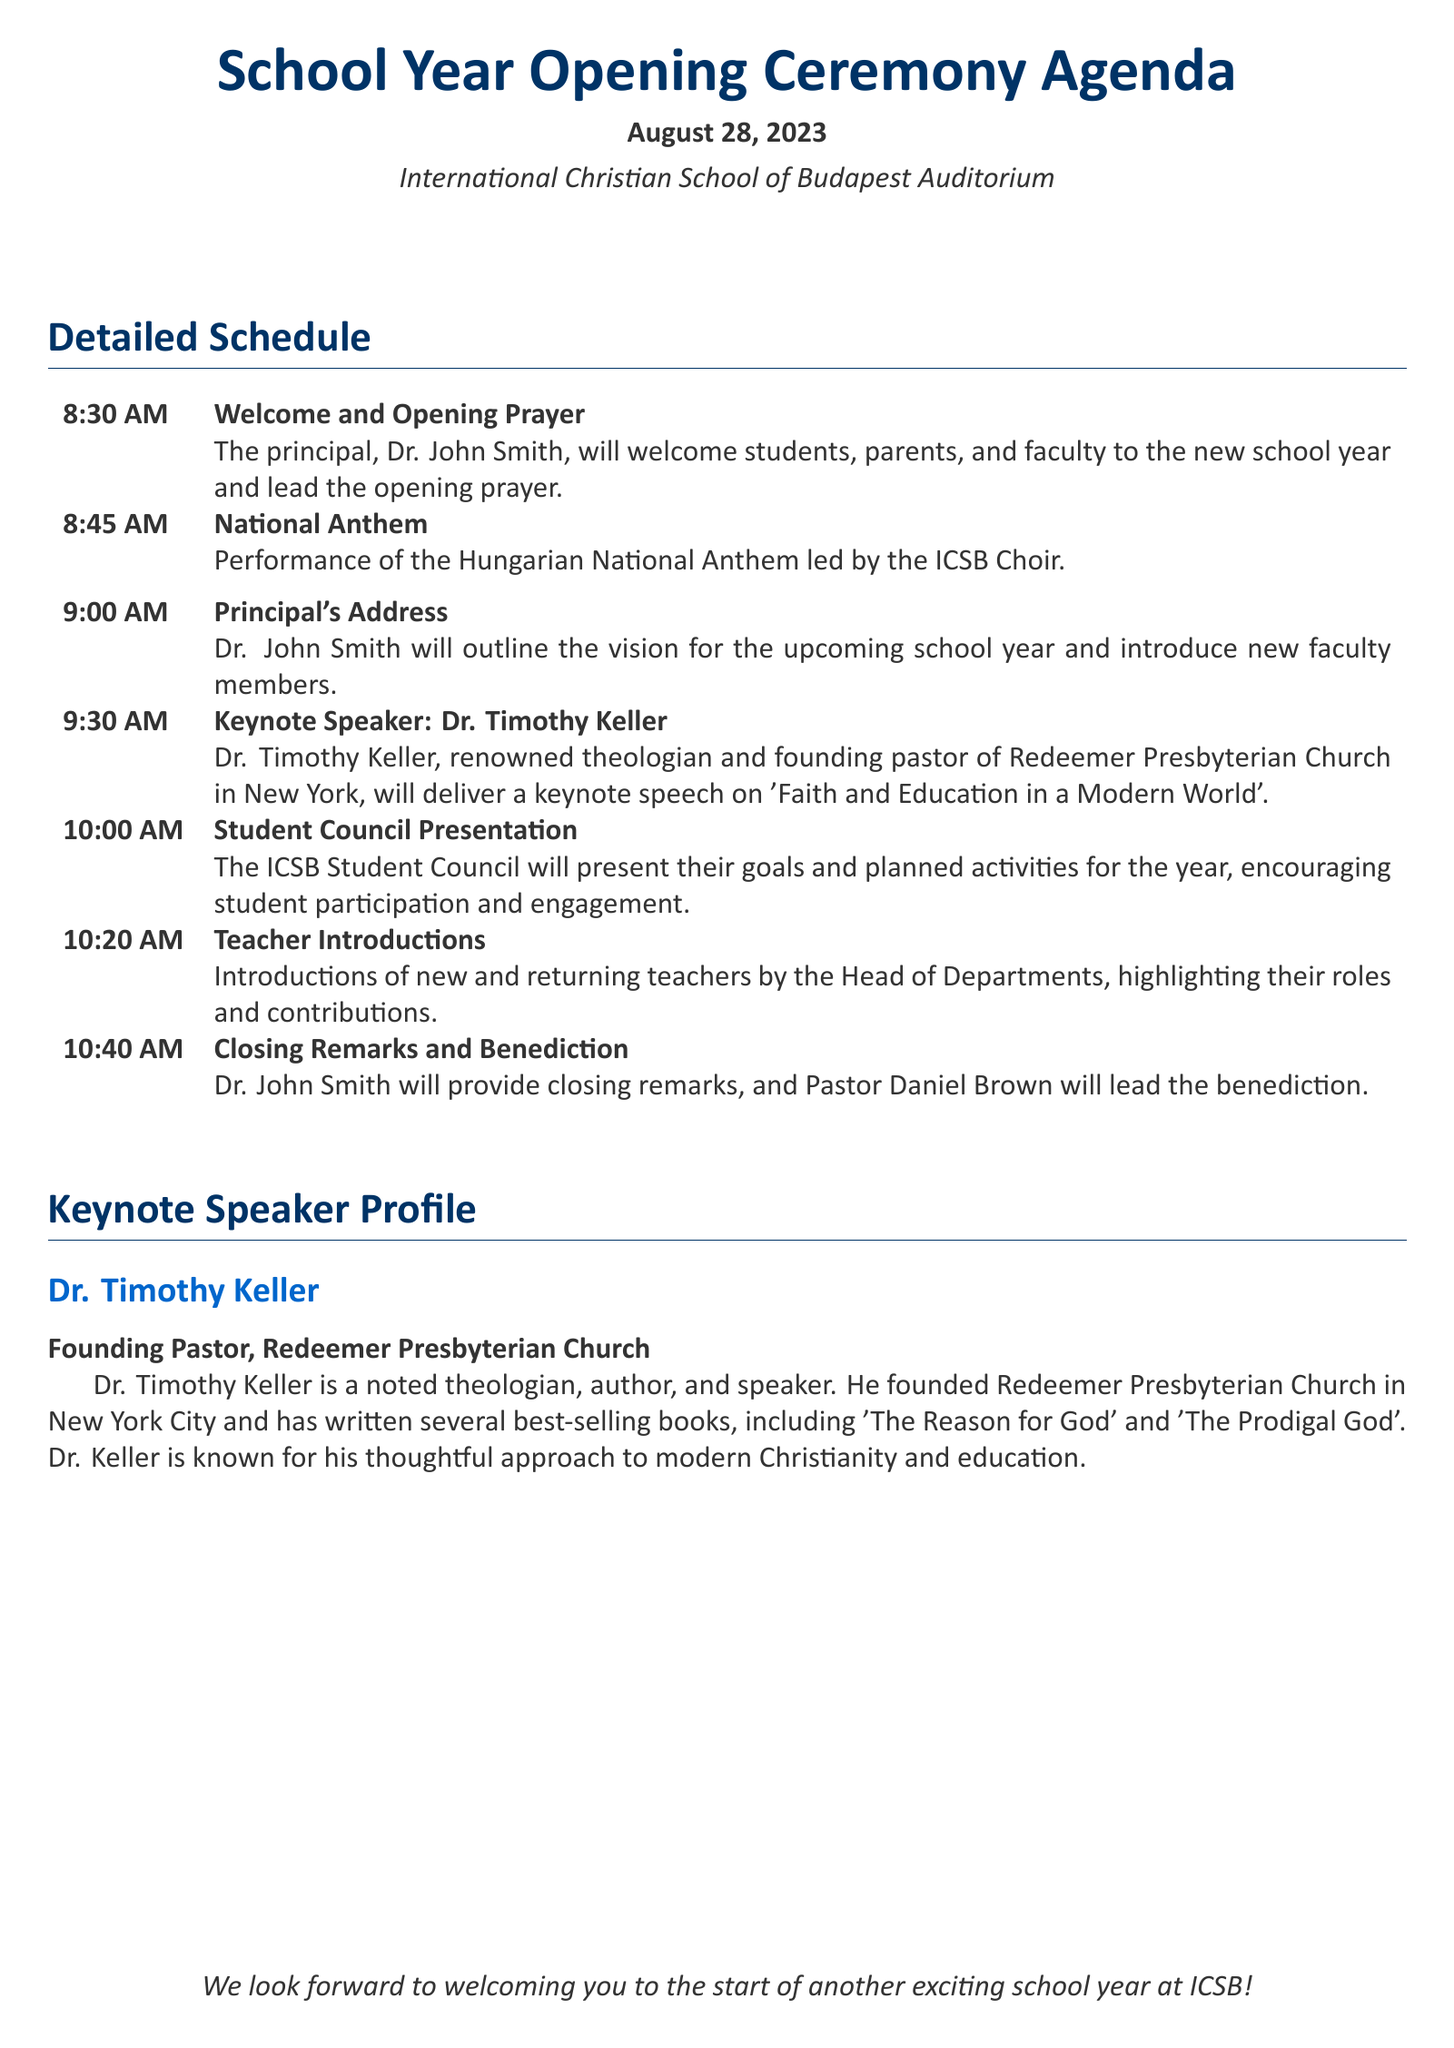What date is the School Year Opening Ceremony? The date of the ceremony is explicitly mentioned in the document.
Answer: August 28, 2023 Who is the keynote speaker? The document provides the name and profile of the keynote speaker.
Answer: Dr. Timothy Keller At what time does the Principal's Address begin? This time is specified in the schedule of the ceremony.
Answer: 9:00 AM What is the title of the keynote speech? The title of the speech is mentioned directly in the agenda.
Answer: Faith and Education in a Modern World Who leads the opening prayer? The person who leads the opening prayer is identified in the schedule.
Answer: Dr. John Smith What will be performed by the ICSB Choir? The document explicitly states what will be performed by the choir.
Answer: Hungarian National Anthem How many key agenda items are listed before the closing remarks? This requires counting the main events listed in the schedule provided.
Answer: 5 What role does Pastor Daniel Brown have in the ceremony? The role of Pastor Daniel Brown is described in the closing section of the agenda.
Answer: Lead the benediction Who provides the closing remarks? The individual responsible for closing remarks is mentioned in the document.
Answer: Dr. John Smith 